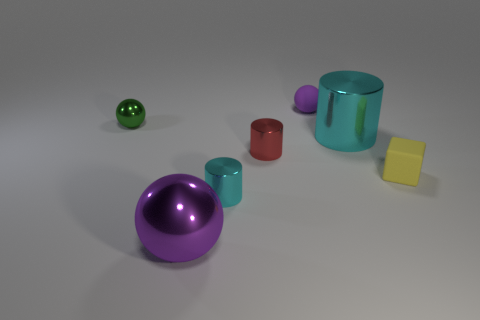What is the material of the tiny ball that is the same color as the large metallic sphere? rubber 